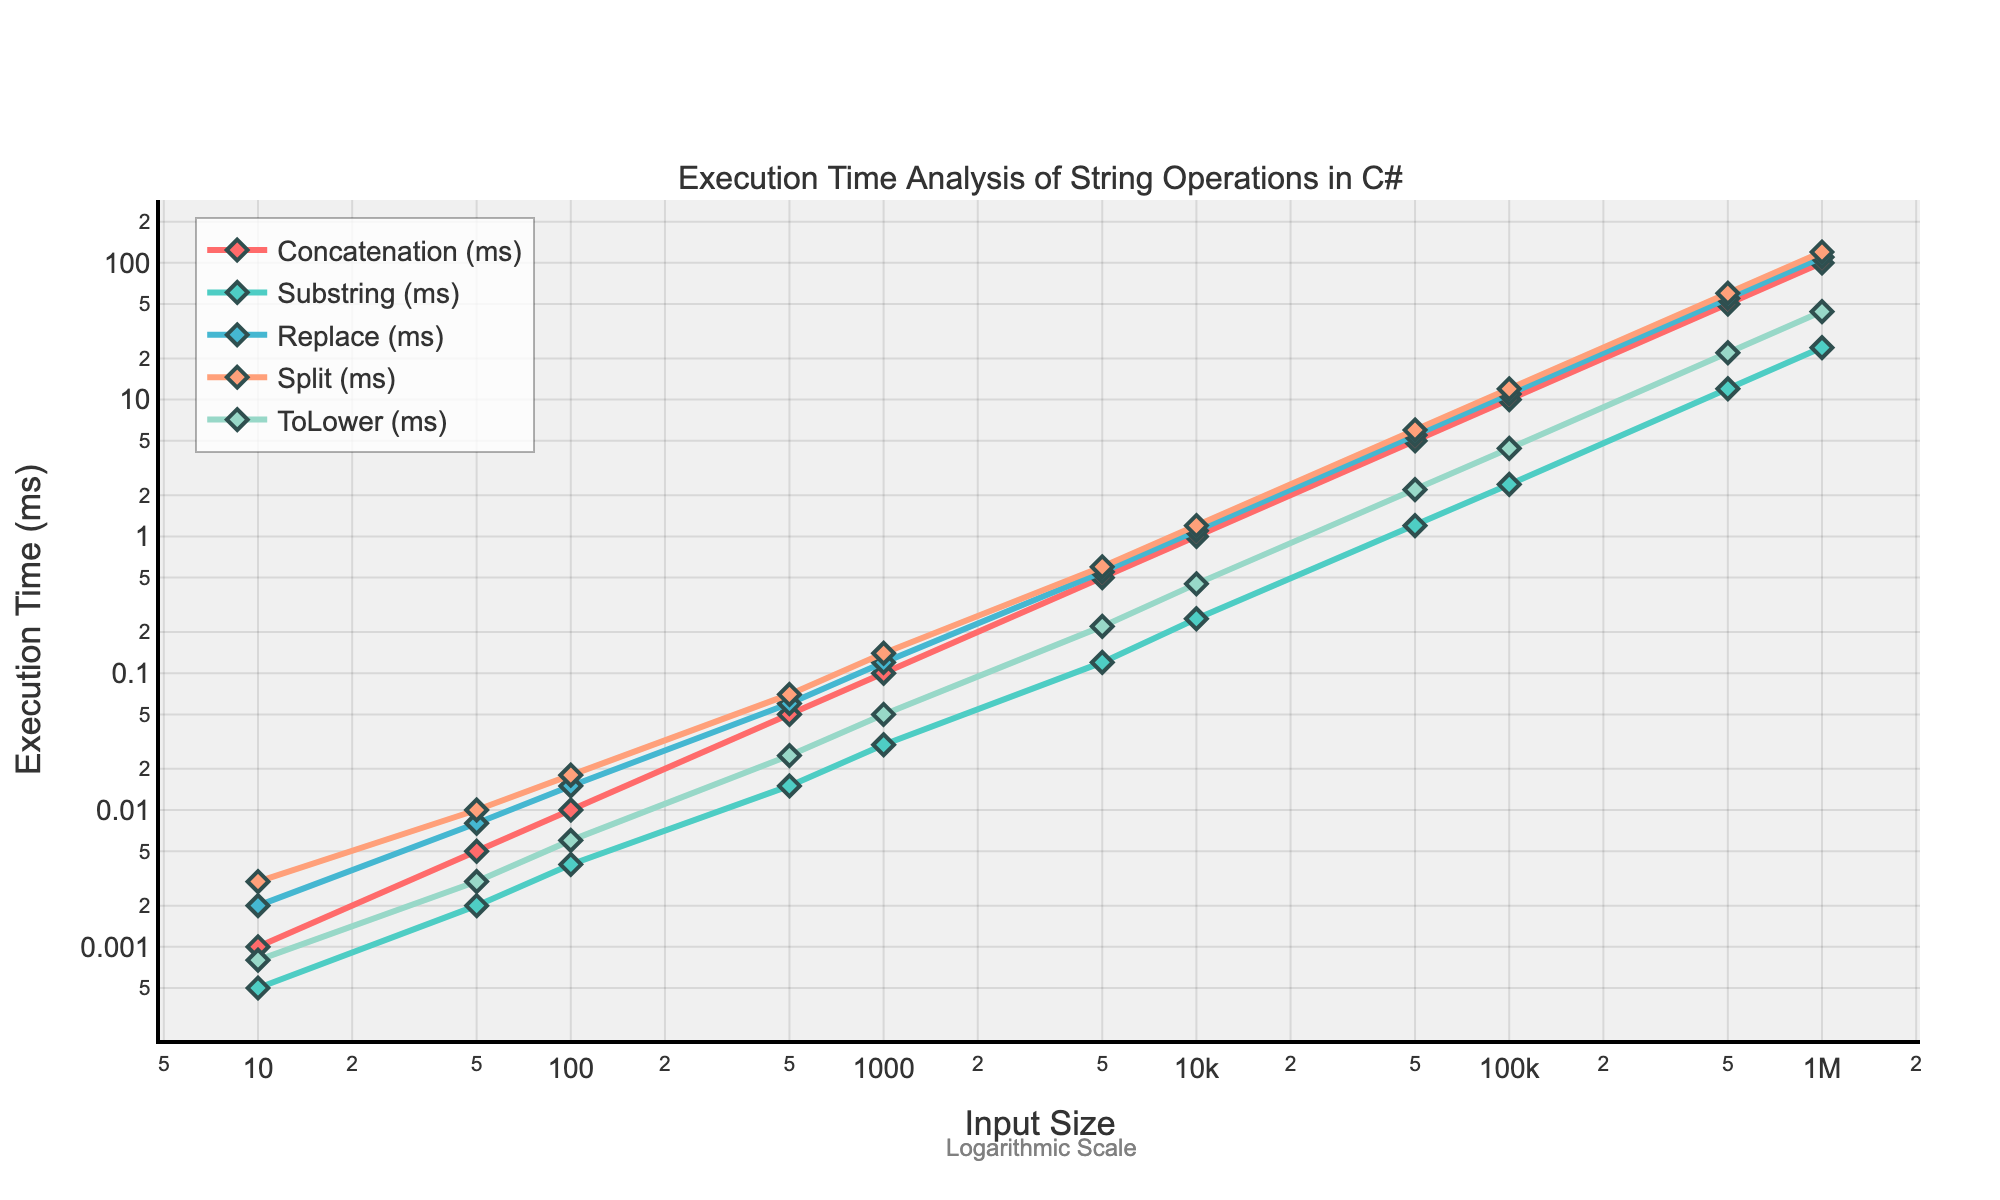What is the execution time of the `ToLower` operation for an input size of 10? To find the execution time of the `ToLower` operation for an input size of 10, locate the point where the `ToLower` line intersects the value 10 on the x-axis and check the corresponding y-value.
Answer: 0.0008 ms Which operation has the highest execution time for an input size of 100? To find the operation with the highest execution time for an input size of 100, identify the y-values for all operations at x=100 and compare them. The highest y-value corresponds to the `Replace` operation.
Answer: Replace How does the execution time of `Concatenation` compare to `Substring` for an input size of 500? Compare the y-values for both operations at x=500. The `Concatenation` time is higher than the `Substring` time.
Answer: Concatenation is higher What is the difference in execution time between `Split` and `Replace` for an input size of 1000? To find this, locate the y-values for `Split` and `Replace` at x=1000 and subtract the `Split` time from the `Replace` time. The difference is 0.14 - 0.12 = 0.02 ms.
Answer: 0.02 ms Which operation has the smallest increase in execution time from input size 100 to 500? Calculate the difference in execution time from size 100 to 500 for each operation: Concatenation increases by 0.04 ms, Substring by 0.011 ms, Replace by 0.045 ms, Split by 0.052 ms, and ToLower by 0.019 ms. The smallest increase is for `Substring`.
Answer: Substring At what input size does `Concatenation` reach an execution time of 1 ms? Find the point on the `Concatenation` line where the y-value is 1 ms. This occurs at an input size of 10000.
Answer: 10000 What is the average execution time of the `Replace` operation for input sizes 10, 50, and 100? Calculate the average execution time by summing the times for input sizes 10, 50, and 100, and dividing by 3: (0.002 + 0.008 + 0.015) / 3 = 0.0083 ms.
Answer: 0.0083 ms How much does the execution time of `Split` increase when moving from an input size of 5000 to 100000? Calculate the difference in execution time from size 5000 to 100000: 12.0 - 0.6 = 11.4 ms.
Answer: 11.4 ms For which input size does `ToLower` take exactly twice the time it takes for `Substring`? Find the point where the `ToLower` y-value is twice the `Substring` y-value. This occurs at input size 50000: `ToLower` time is 2.2 ms and `Substring` time is 1.2 ms.
Answer: 50000 